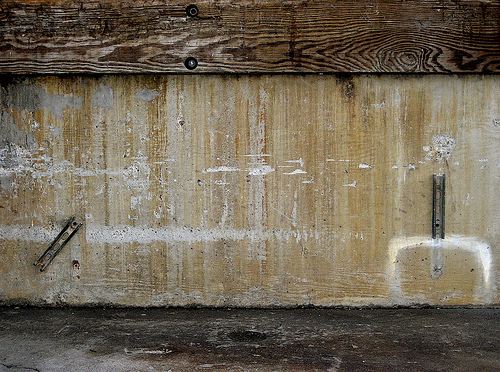<image>
Is there a metal on the floor? No. The metal is not positioned on the floor. They may be near each other, but the metal is not supported by or resting on top of the floor. 